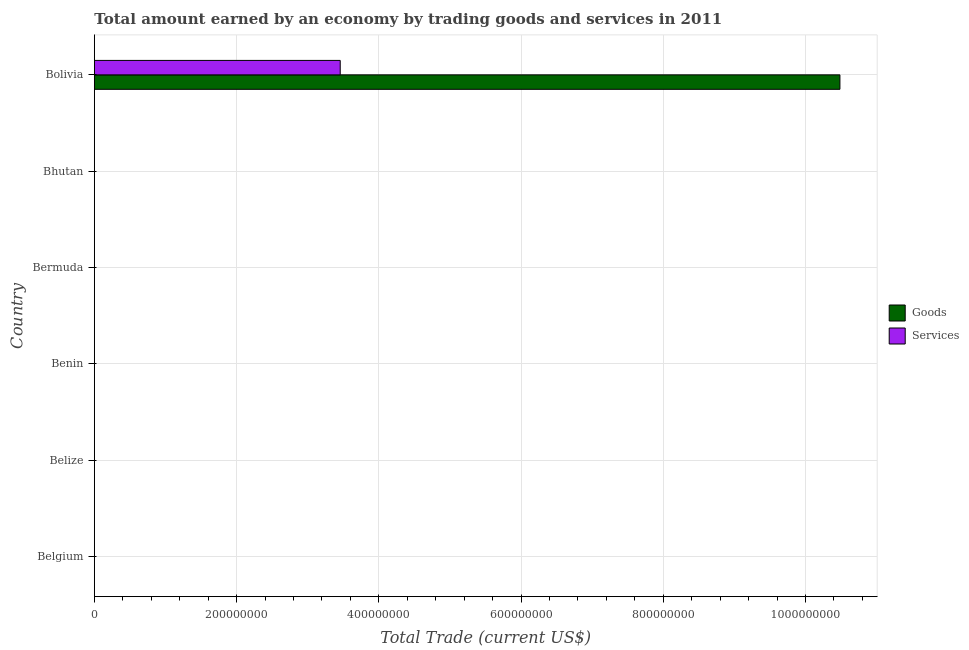Are the number of bars per tick equal to the number of legend labels?
Your response must be concise. No. Are the number of bars on each tick of the Y-axis equal?
Offer a terse response. No. In how many cases, is the number of bars for a given country not equal to the number of legend labels?
Offer a terse response. 5. What is the amount earned by trading goods in Belgium?
Offer a very short reply. 0. Across all countries, what is the maximum amount earned by trading goods?
Ensure brevity in your answer.  1.05e+09. In which country was the amount earned by trading goods maximum?
Make the answer very short. Bolivia. What is the total amount earned by trading services in the graph?
Keep it short and to the point. 3.46e+08. What is the difference between the amount earned by trading goods in Bermuda and the amount earned by trading services in Belize?
Your answer should be very brief. 0. What is the average amount earned by trading goods per country?
Give a very brief answer. 1.75e+08. What is the difference between the amount earned by trading services and amount earned by trading goods in Bolivia?
Ensure brevity in your answer.  -7.03e+08. What is the difference between the highest and the lowest amount earned by trading goods?
Offer a very short reply. 1.05e+09. Are all the bars in the graph horizontal?
Ensure brevity in your answer.  Yes. Does the graph contain grids?
Make the answer very short. Yes. Where does the legend appear in the graph?
Provide a short and direct response. Center right. What is the title of the graph?
Your answer should be very brief. Total amount earned by an economy by trading goods and services in 2011. What is the label or title of the X-axis?
Provide a succinct answer. Total Trade (current US$). What is the Total Trade (current US$) in Goods in Belgium?
Make the answer very short. 0. What is the Total Trade (current US$) of Goods in Belize?
Provide a short and direct response. 0. What is the Total Trade (current US$) of Services in Belize?
Offer a very short reply. 0. What is the Total Trade (current US$) of Goods in Benin?
Provide a succinct answer. 0. What is the Total Trade (current US$) of Services in Bermuda?
Your answer should be very brief. 0. What is the Total Trade (current US$) in Goods in Bhutan?
Offer a terse response. 0. What is the Total Trade (current US$) of Services in Bhutan?
Your response must be concise. 0. What is the Total Trade (current US$) in Goods in Bolivia?
Your answer should be very brief. 1.05e+09. What is the Total Trade (current US$) of Services in Bolivia?
Give a very brief answer. 3.46e+08. Across all countries, what is the maximum Total Trade (current US$) of Goods?
Your answer should be compact. 1.05e+09. Across all countries, what is the maximum Total Trade (current US$) in Services?
Make the answer very short. 3.46e+08. Across all countries, what is the minimum Total Trade (current US$) of Services?
Ensure brevity in your answer.  0. What is the total Total Trade (current US$) in Goods in the graph?
Your response must be concise. 1.05e+09. What is the total Total Trade (current US$) of Services in the graph?
Provide a short and direct response. 3.46e+08. What is the average Total Trade (current US$) of Goods per country?
Make the answer very short. 1.75e+08. What is the average Total Trade (current US$) in Services per country?
Make the answer very short. 5.76e+07. What is the difference between the Total Trade (current US$) of Goods and Total Trade (current US$) of Services in Bolivia?
Ensure brevity in your answer.  7.03e+08. What is the difference between the highest and the lowest Total Trade (current US$) of Goods?
Your response must be concise. 1.05e+09. What is the difference between the highest and the lowest Total Trade (current US$) of Services?
Your answer should be compact. 3.46e+08. 